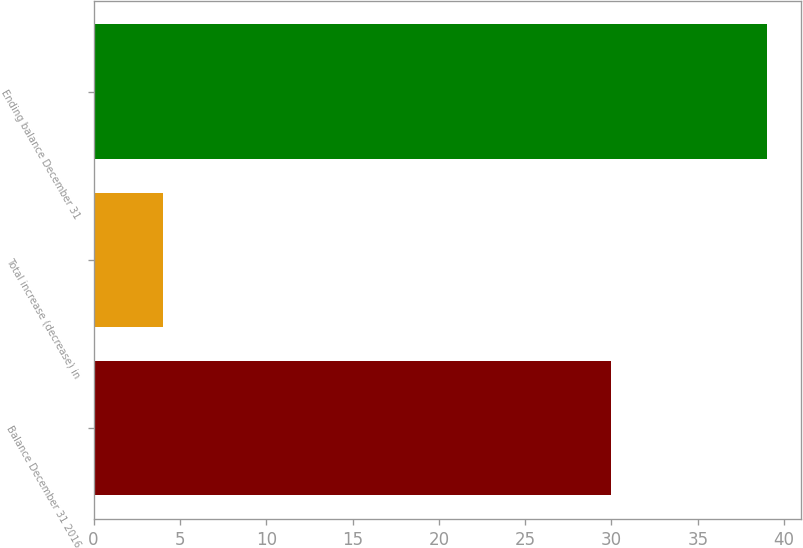<chart> <loc_0><loc_0><loc_500><loc_500><bar_chart><fcel>Balance December 31 2016<fcel>Total increase (decrease) in<fcel>Ending balance December 31<nl><fcel>30<fcel>4<fcel>39<nl></chart> 